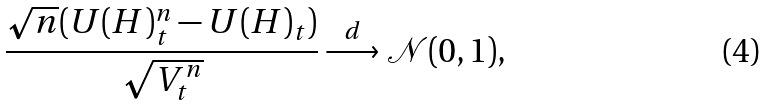Convert formula to latex. <formula><loc_0><loc_0><loc_500><loc_500>\frac { \sqrt { n } ( U ( H ) _ { t } ^ { n } - U ( H ) _ { t } ) } { \sqrt { V _ { t } ^ { n } } } \stackrel { d } { \longrightarrow } \mathcal { N } ( 0 , 1 ) ,</formula> 